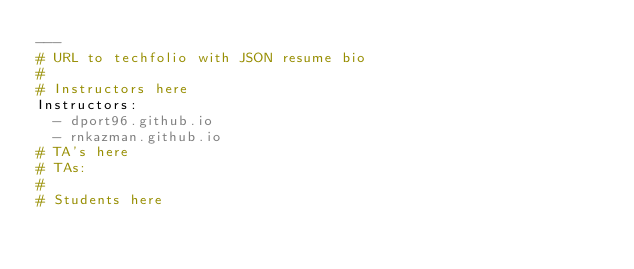<code> <loc_0><loc_0><loc_500><loc_500><_YAML_>---
# URL to techfolio with JSON resume bio
#
# Instructors here
Instructors:
  - dport96.github.io
  - rnkazman.github.io
# TA's here
# TAs:
#
# Students here</code> 